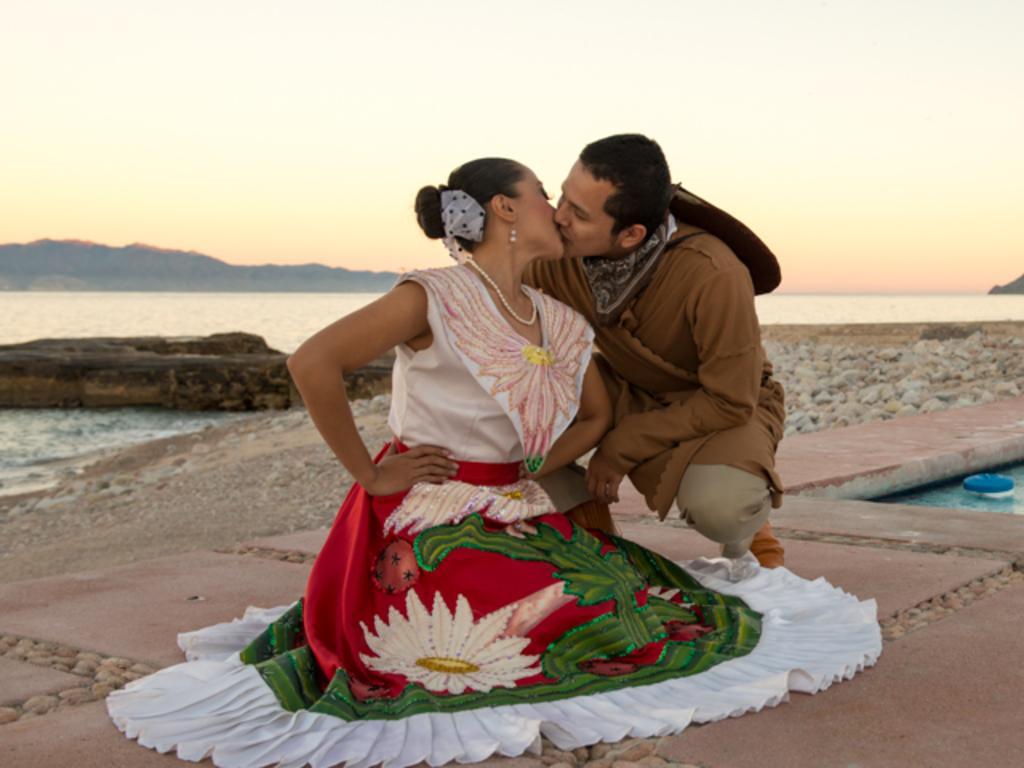Can you describe this image briefly? In the center of the image we can see man and woman sitting on the ground. In the background we can see stones, water, hill and sky. 